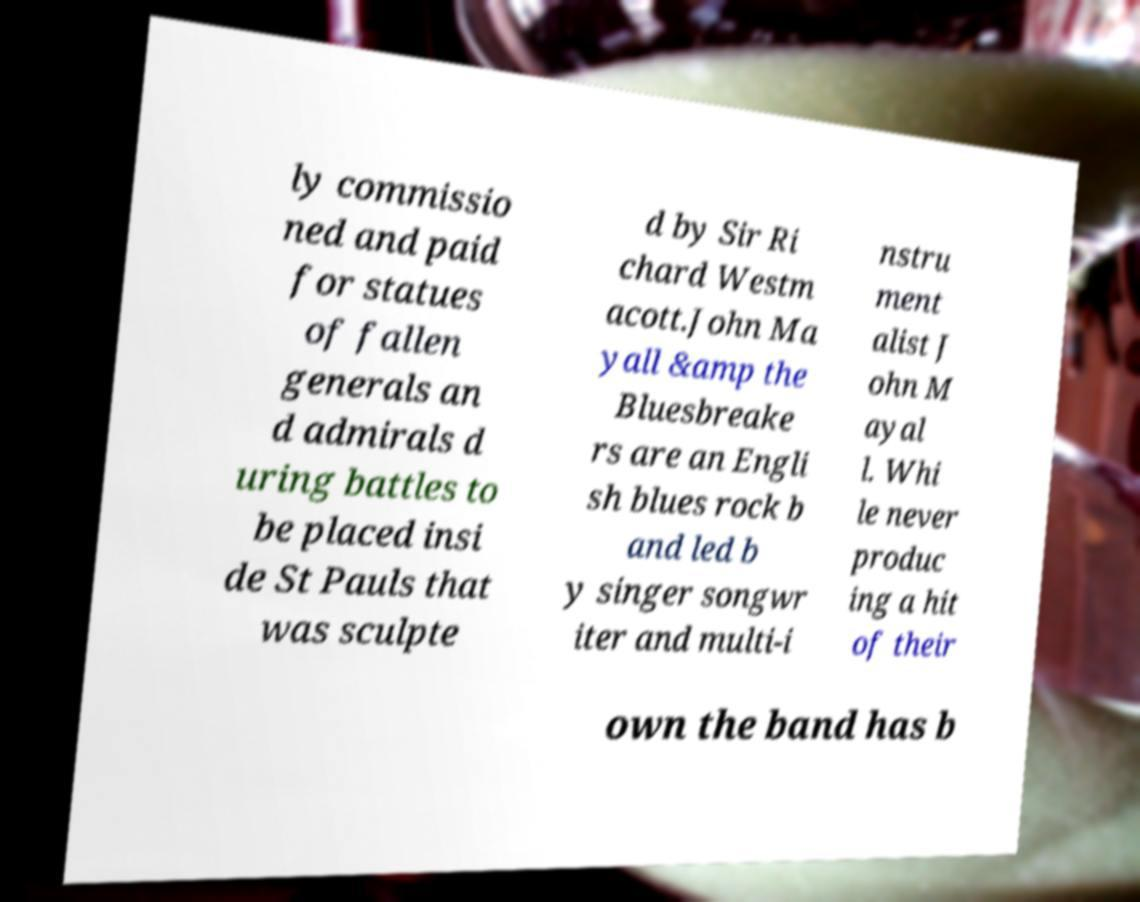Please identify and transcribe the text found in this image. ly commissio ned and paid for statues of fallen generals an d admirals d uring battles to be placed insi de St Pauls that was sculpte d by Sir Ri chard Westm acott.John Ma yall &amp the Bluesbreake rs are an Engli sh blues rock b and led b y singer songwr iter and multi-i nstru ment alist J ohn M ayal l. Whi le never produc ing a hit of their own the band has b 